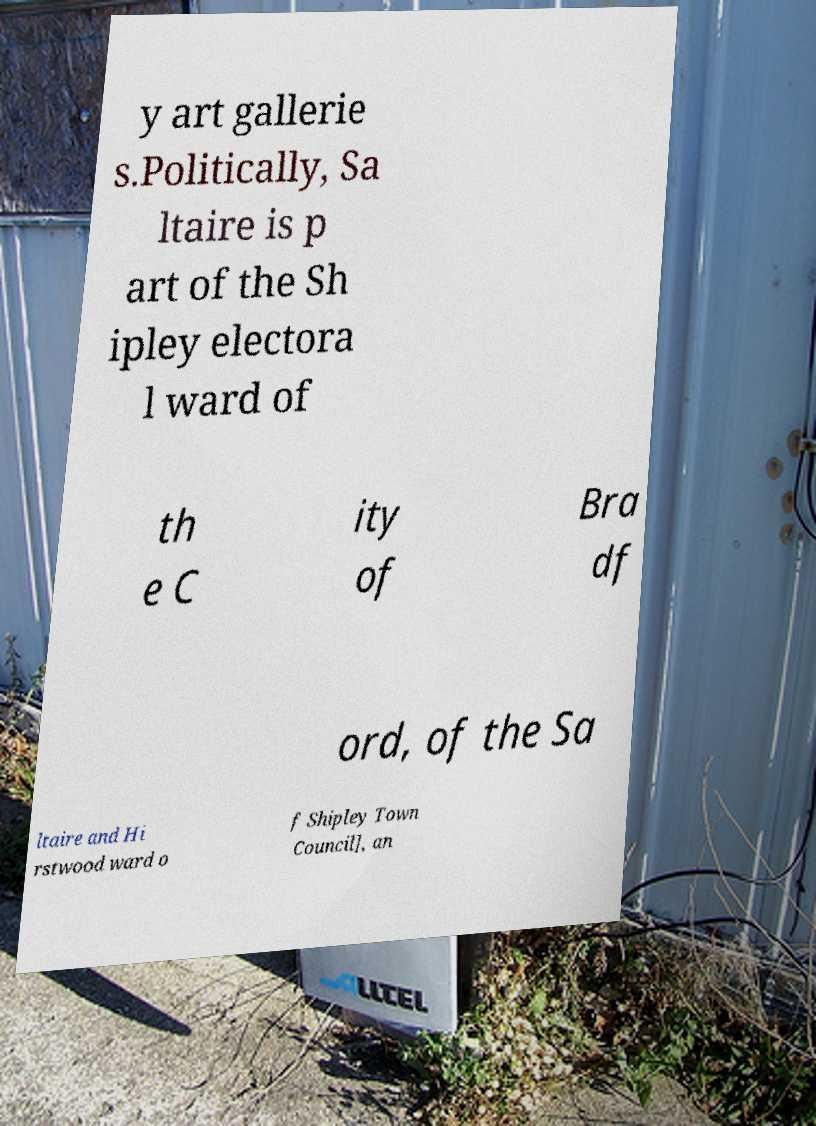Please read and relay the text visible in this image. What does it say? y art gallerie s.Politically, Sa ltaire is p art of the Sh ipley electora l ward of th e C ity of Bra df ord, of the Sa ltaire and Hi rstwood ward o f Shipley Town Council], an 